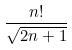Convert formula to latex. <formula><loc_0><loc_0><loc_500><loc_500>\frac { n ! } { \sqrt { 2 n + 1 } }</formula> 